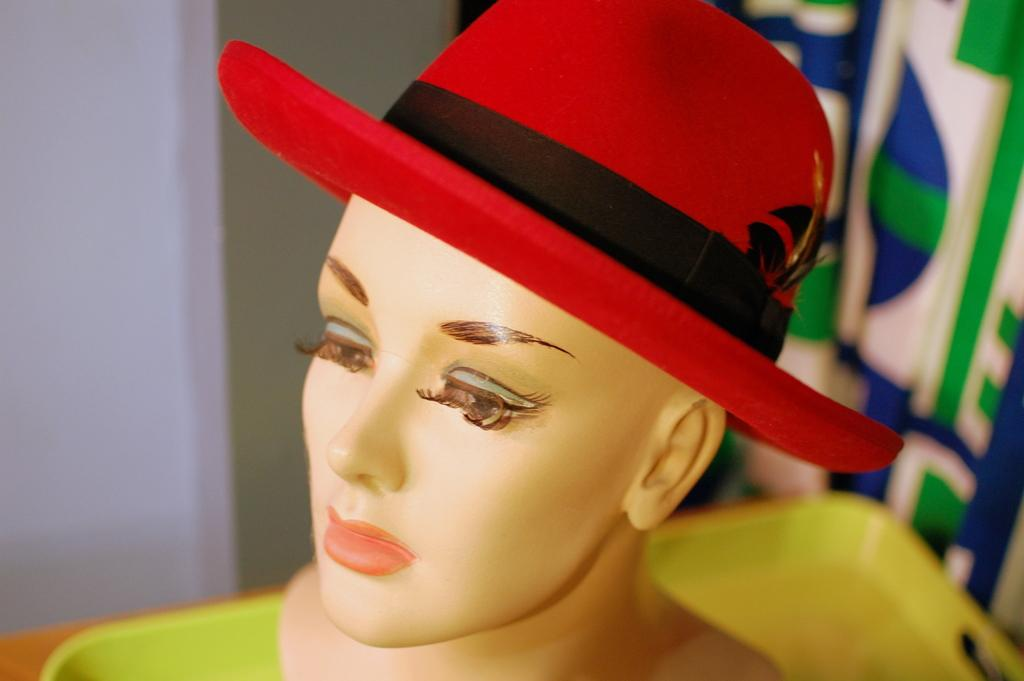What is the main subject in the foreground of the image? There is a mannequin with a hat in the foreground of the image. What can be seen in the background of the image? There appears to be a tray in the background of the image. Can you describe the objects in the background in more detail? Unfortunately, the remaining objects in the background are not clear. What type of toothpaste is being used by the mannequin in the image? There is no toothpaste present in the image, as it features a mannequin with a hat in the foreground and a tray in the background. 